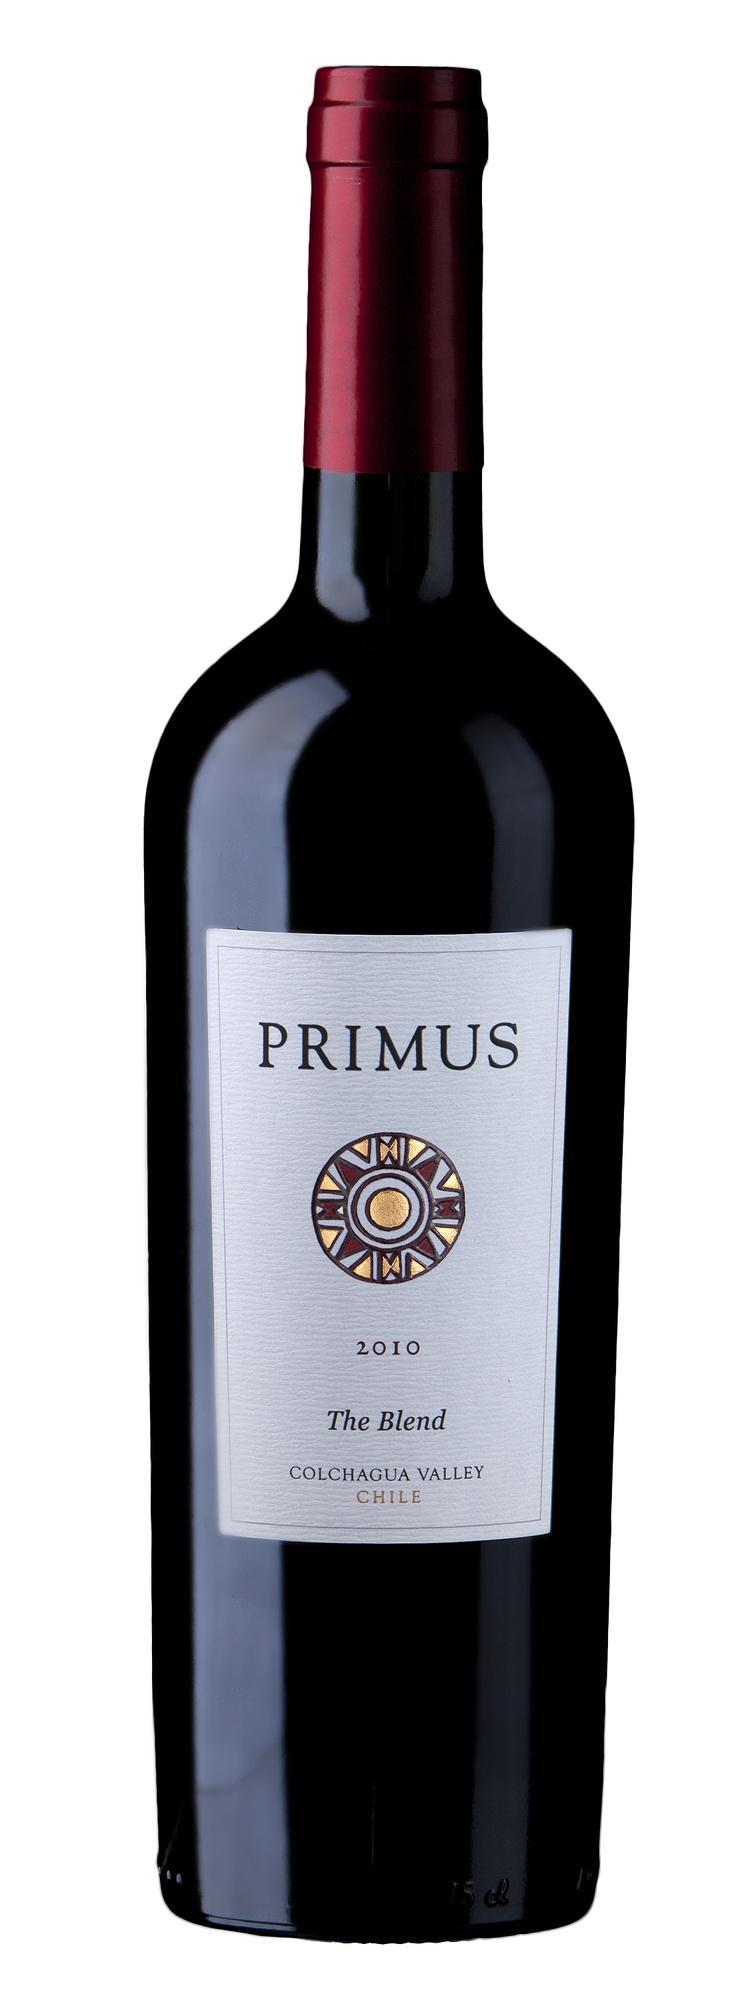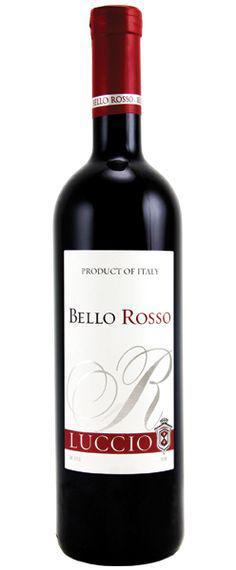The first image is the image on the left, the second image is the image on the right. Given the left and right images, does the statement "The bottle in the image on the left has a screw-off cap." hold true? Answer yes or no. No. 